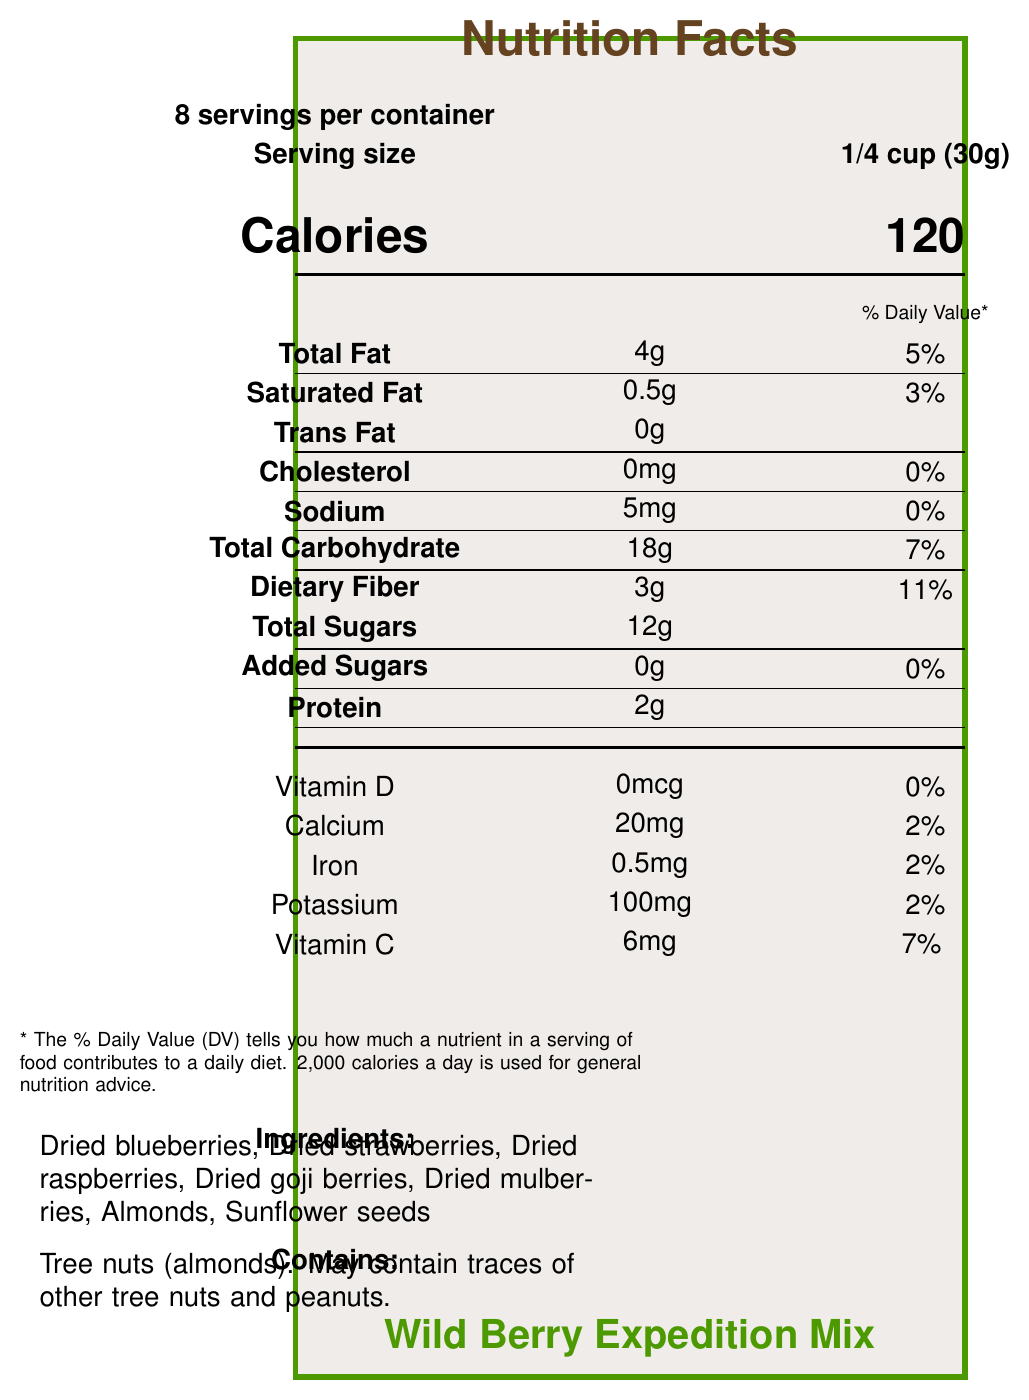what is the serving size for the Wild Berry Expedition Mix? The serving size is clearly stated in the serving information section of the document.
Answer: 1/4 cup (30g) how many servings are there per container of the Wild Berry Expedition Mix? The document states there are 8 servings per container.
Answer: 8 what is the amount of total fat per serving? The amount of total fat per serving is listed under the nutrient information section.
Answer: 4g how much dietary fiber is in one serving? The dietary fiber content for one serving is listed in the nutrient information section.
Answer: 3g how much protein is in one serving? The protein content for one serving is indicated in the nutrient information section.
Answer: 2g how many calories are in one serving? The calorie content per serving is prominently displayed in the document.
Answer: 120 how much vitamin C is in one serving? The vitamin C content per serving is listed under the vitamin and mineral information section.
Answer: 6mg how much calcium does one serving provide? The calcium content for one serving is included in the vitamin and mineral information section.
Answer: 20mg how many ingredients are listed in the Wild Berry Expedition Mix? The ingredients section lists seven different items.
Answer: 7 does the Wild Berry Expedition Mix contain any artificial preservatives? The additional info section explicitly states that the mix contains no artificial preservatives.
Answer: No which of the following is an ingredient in the Wild Berry Expedition Mix? A. Walnuts B. Cashews C. Almonds The ingredients section lists almonds, but not walnuts or cashews.
Answer: C how much is the % Daily Value of iron in one serving? A. 0% B. 2% C. 5% D. 7% The % Daily Value of iron per serving is listed as 2% in the vitamin and mineral information section.
Answer: B is there any cholesterol in the Wild Berry Expedition Mix? The nutrient information section shows that the cholesterol amount is 0mg.
Answer: No how should the Wild Berry Expedition Mix be stored? The storage instructions clearly state these requirements.
Answer: In a cool, dry place, and reseal the bag after opening to maintain freshness does the product include any tree nuts? The allergen information states that the product contains tree nuts (almonds).
Answer: Yes what additional information is provided about the product? The additional information section provides these details.
Answer: Packed with antioxidants for long days in the field, no artificial preservatives or added sugars, sourced from sustainable wild berry farms, perfect for maintaining energy during wildlife photography expeditions, supports habitat restoration projects through packaging made from recycled materials. who is the manufacturer of the Wild Berry Expedition Mix? The manufacturer's name is given at the bottom of the document.
Answer: Nature's Lens Nutrition why is the Wild Berry Expedition Mix suitable for wildlife photographers? The additional information section explains these benefits clearly.
Answer: Because it is packed with antioxidants, has no artificial preservatives or added sugars, is high in energy, and supports habitat restoration projects. does the document mention the price of the Wild Berry Expedition Mix? The document does not provide any pricing information for the product.
Answer: Not enough information summarize the key nutritional and additional characteristics of the Wild Berry Expedition Mix. The summary includes the key nutritional components, ingredients, manufacturer details, and additional characteristics that highlight the suitability of the mix for wildlife photographers.
Answer: The Wild Berry Expedition Mix offers 120 calories per 1/4 cup serving, with moderate amounts of fat, carbohydrate, dietary fiber, and sugars, while being free from cholesterol and trans fats. It is rich in antioxidants and contains ingredients like dried blueberries and almonds. The product is manufactured by Nature's Lens Nutrition and is designed to be energy-sustaining for fieldwork, with a commitment to sustainable practices and no artificial additives. 